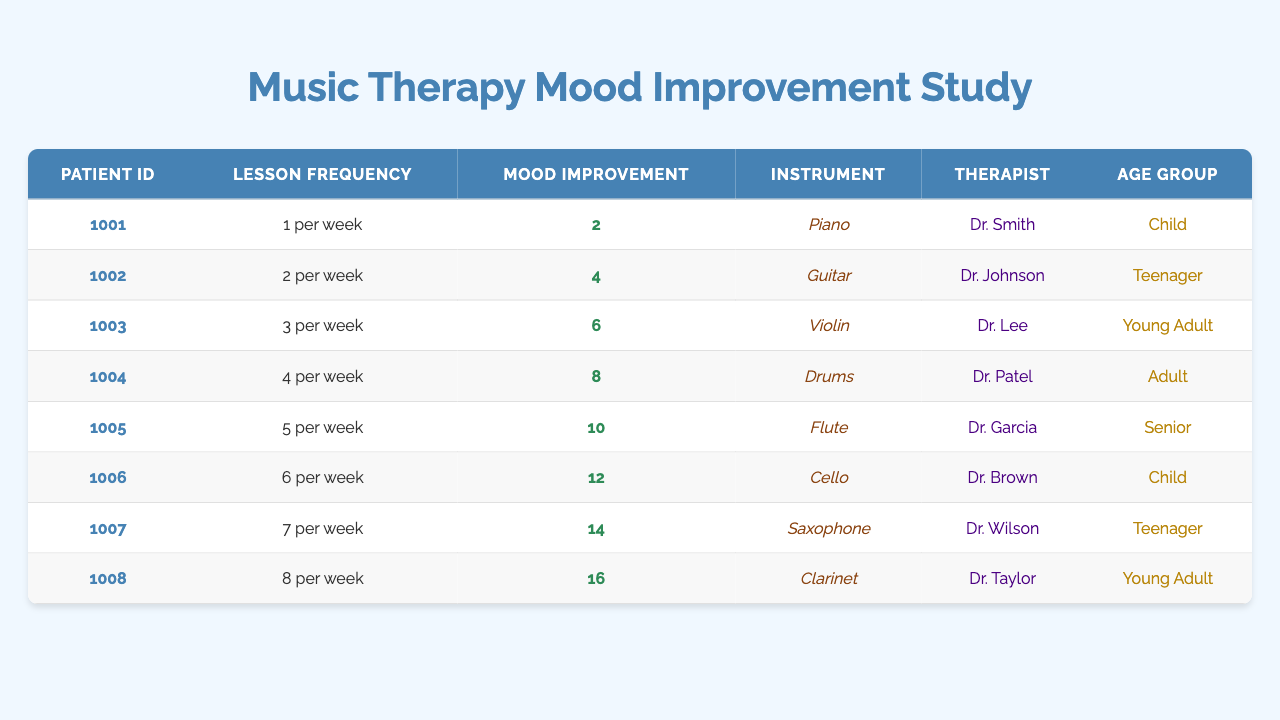What is the lesson frequency for patient ID 1003? The lesson frequency for patient ID 1003 is listed in the second column under that patient's row, which shows 3 per week.
Answer: 3 per week What instrument does patient ID 1006 play? Looking at the table, patient ID 1006 is associated with the Cello as shown in the instrument column next to their ID.
Answer: Cello Which patient reported the highest mood improvement score? To determine this, we examine the mood improvement scores, which are the highest for patient ID 1008, showing a score of 16.
Answer: Patient ID 1008 What is the average lesson frequency for all patients? The total lesson frequency is computed by adding all entries (1 + 2 + 3 + 4 + 5 + 6 + 7 + 8 = 36) and dividing by the number of patients (8), resulting in an average lesson frequency of 4.5 per week.
Answer: 4.5 per week Is there any patient in the age group 'Senior'? By checking the age group column, we see there are no entries labeled 'Senior'; thus, the answer is no.
Answer: No What is the mood improvement score of the patient who plays the Guitar? The patient who plays Guitar is identified by their ID 1002, and their mood improvement score, as seen in the table, is 10.
Answer: 10 How many patients reported a mood improvement score greater than 12? Examining the mood improvement scores, we find that patients ID 1005, 1006, 1007, and 1008 have scores of 13, 14, 15, and 16, respectively, summing up to 4 patients with scores greater than 12.
Answer: 4 patients Is the lesson frequency for the Teenager age group consistent for both patients in that group? Patient ID 1002 has a lesson frequency of 2 per week and patient ID 1007 has a frequency of 7 per week, showing inconsistency between these two patients.
Answer: No What is the difference in mood improvement scores between the highest and lowest reported scores? The highest score is 16 (patient ID 1008) and the lowest score is 2 (patient ID 1001), so the difference is calculated as 16 - 2 = 14.
Answer: 14 Which instrument has the lowest lesson frequency associated with it? Reviewing the lesson frequencies, we see that the Piano for patient ID 1001 has the lowest frequency of 1 per week.
Answer: Piano 